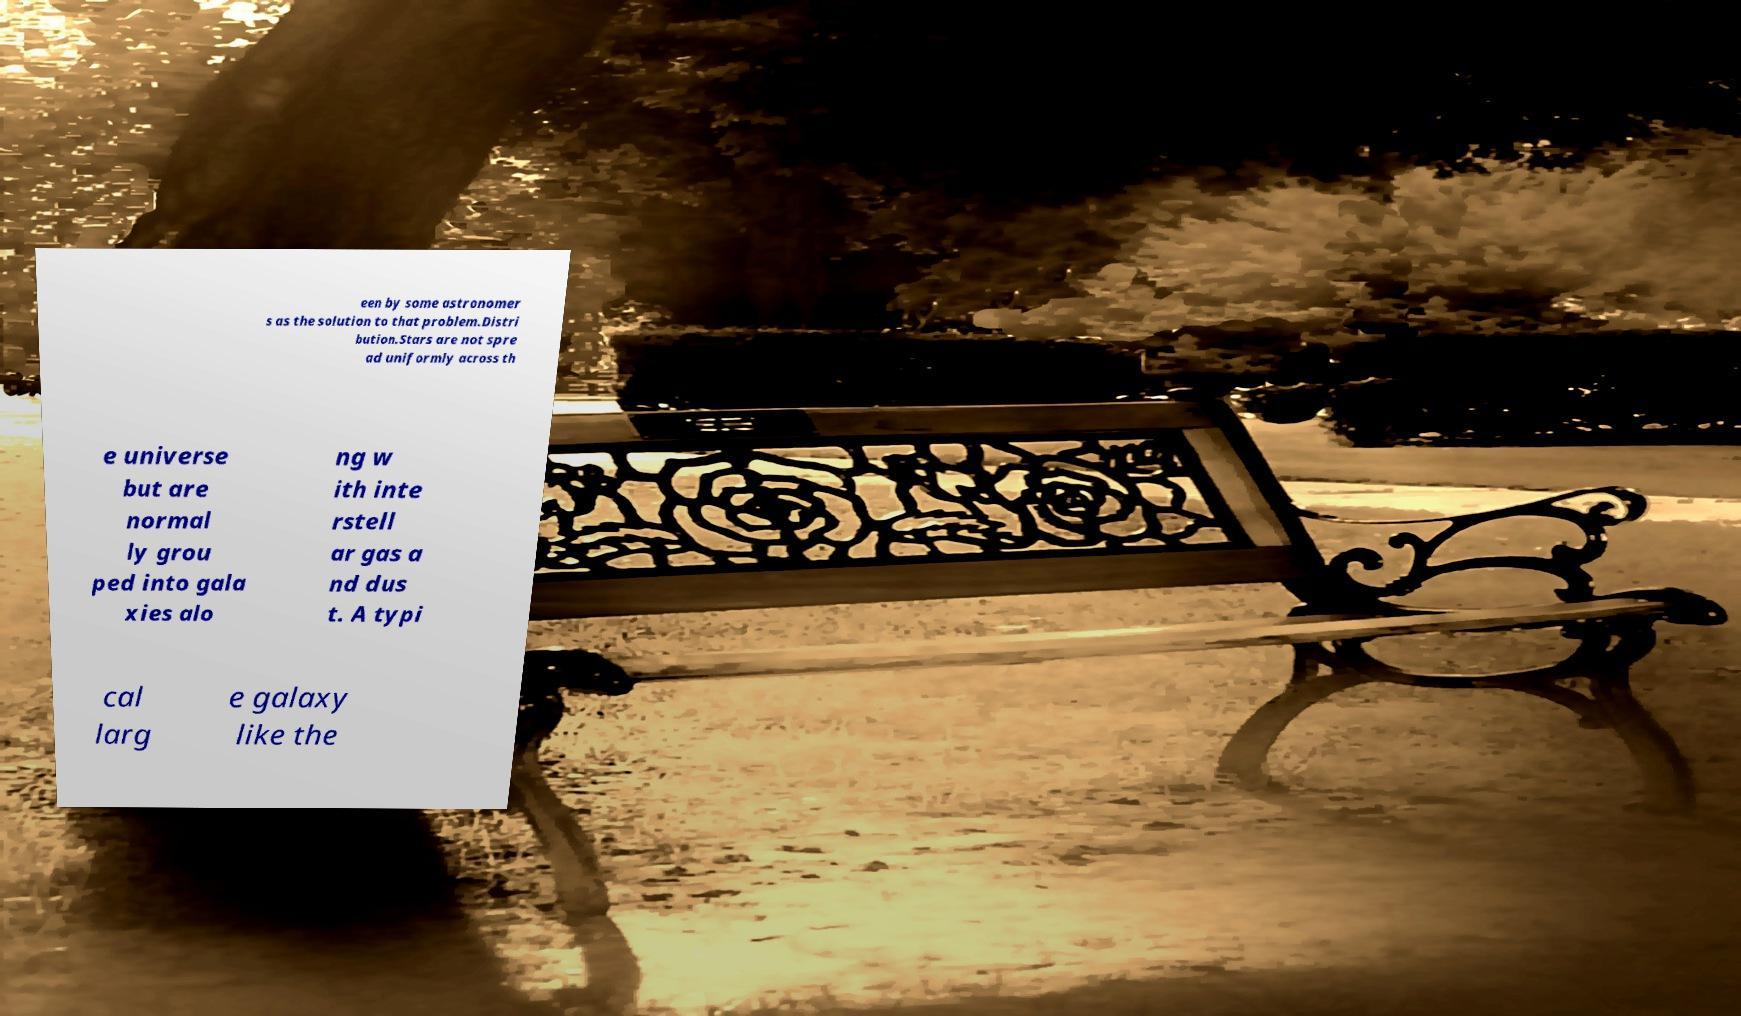Please read and relay the text visible in this image. What does it say? een by some astronomer s as the solution to that problem.Distri bution.Stars are not spre ad uniformly across th e universe but are normal ly grou ped into gala xies alo ng w ith inte rstell ar gas a nd dus t. A typi cal larg e galaxy like the 